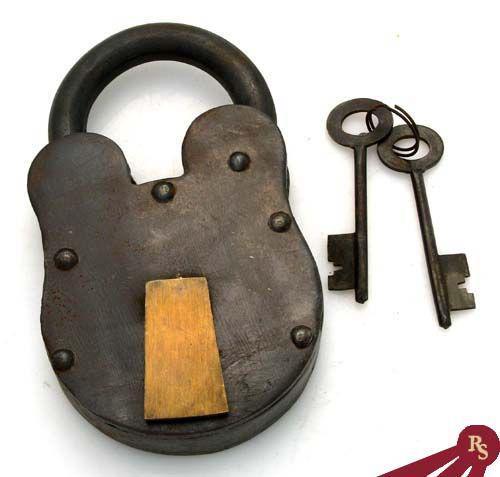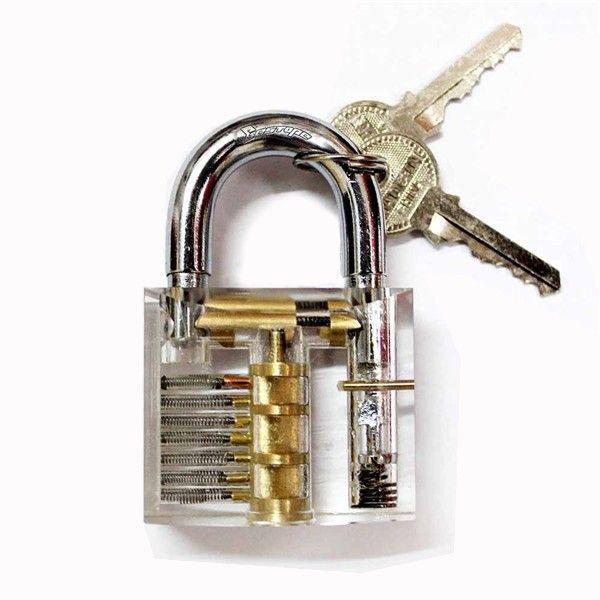The first image is the image on the left, the second image is the image on the right. Examine the images to the left and right. Is the description "An image shows a lock decorated with a human-like figure on its front and with a keyring attached." accurate? Answer yes or no. No. The first image is the image on the left, the second image is the image on the right. For the images shown, is this caption "In one of the images there is a lock with an image carved on the front and two keys attached to it." true? Answer yes or no. No. 